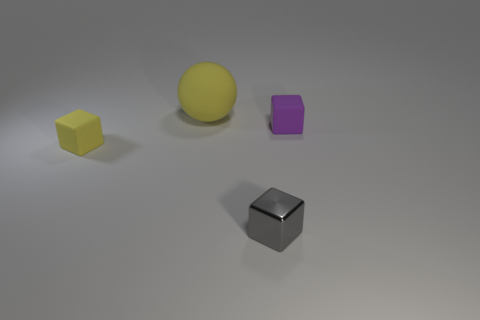Add 2 purple rubber things. How many objects exist? 6 Subtract all gray cubes. How many cubes are left? 2 Subtract 1 blocks. How many blocks are left? 2 Subtract all blocks. How many objects are left? 1 Add 3 small shiny cubes. How many small shiny cubes are left? 4 Add 1 small yellow things. How many small yellow things exist? 2 Subtract 0 green cylinders. How many objects are left? 4 Subtract all tiny cubes. Subtract all cyan cylinders. How many objects are left? 1 